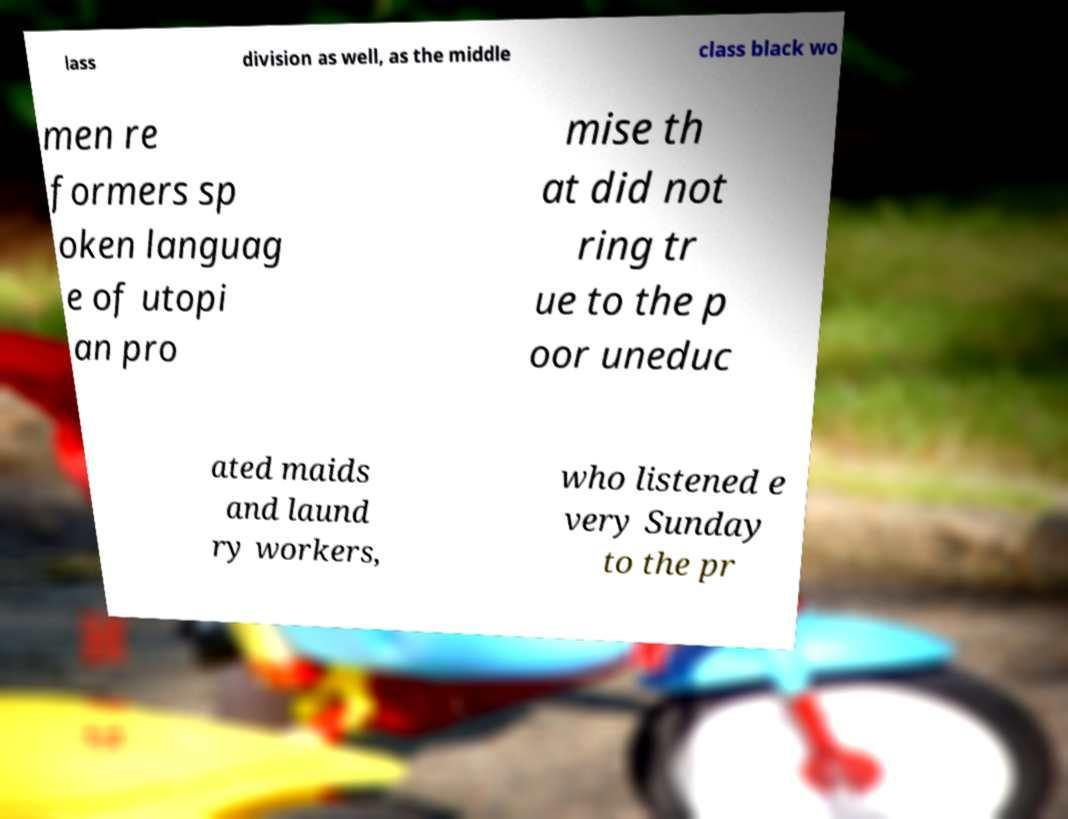What messages or text are displayed in this image? I need them in a readable, typed format. lass division as well, as the middle class black wo men re formers sp oken languag e of utopi an pro mise th at did not ring tr ue to the p oor uneduc ated maids and laund ry workers, who listened e very Sunday to the pr 